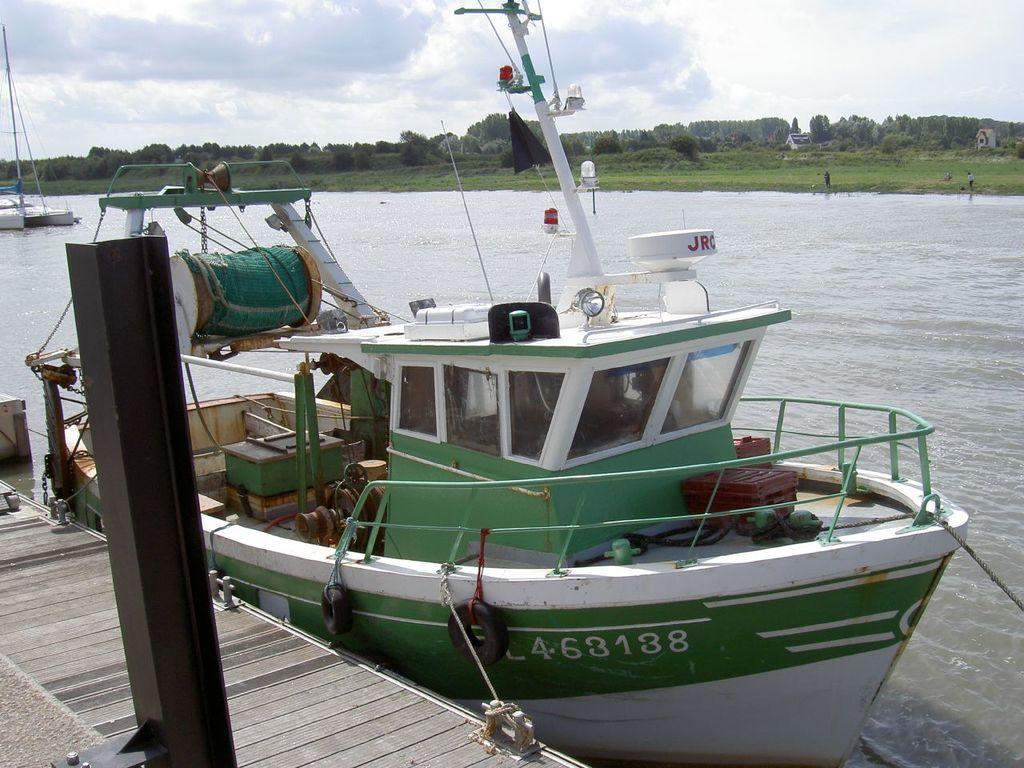What structure can be seen in the image? There is a dock in the image. What type of vehicle is in the image? A boat is present in the image. What can be seen in the background of the image? There is greenery in the background of the image. What is visible at the top of the image? The sky is visible at the top of the image. Where is the tramp located in the image? There is no tramp present in the image. What type of band is playing in the background of the image? There is no band present in the image; it features a dock, a boat, greenery, and the sky. 